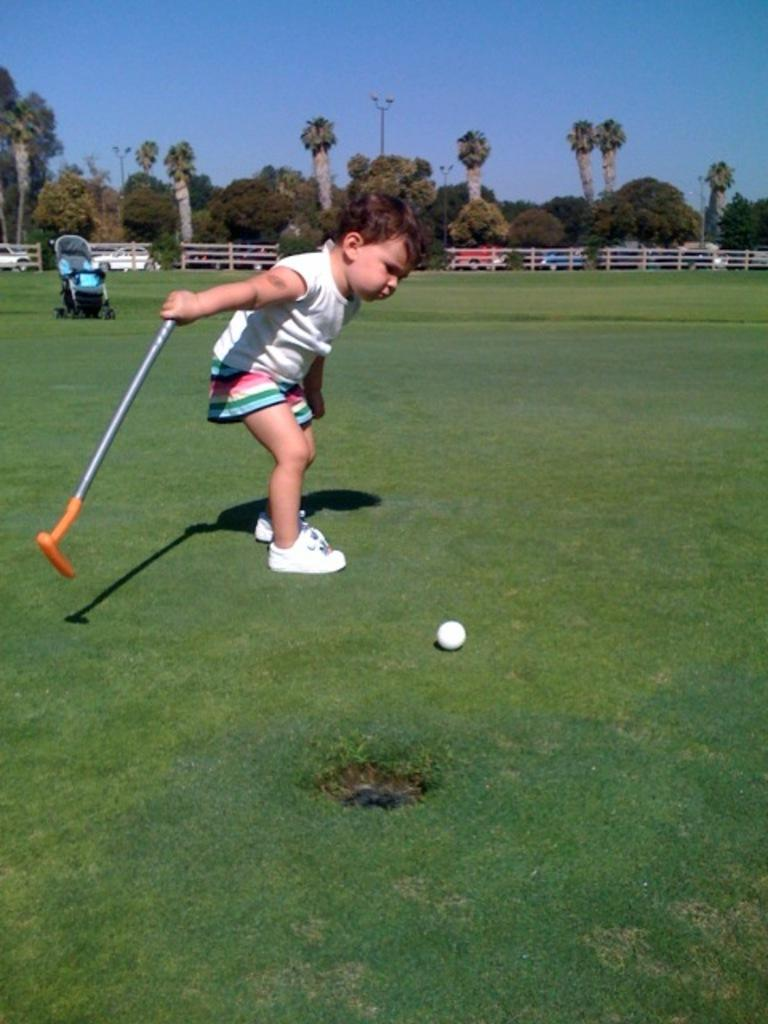What is the main subject of the image? There is a child in the image. What is the child holding in the image? The child is holding a stick and a ball. What is on the ground near the child? There is a stroller on the ground in the image. What can be seen in the background of the image? The sky is visible in the background of the image. Can you tell me how many pears are hanging from the trees in the image? There are no pears visible in the image; only a child, a stick, a ball, a stroller, a fence, vehicles, poles, trees, and the sky are present. 